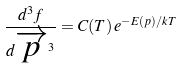Convert formula to latex. <formula><loc_0><loc_0><loc_500><loc_500>\frac { d ^ { 3 } f } { d \overrightarrow { p } ^ { 3 } } = C ( T ) \, e ^ { - E ( p ) / k T }</formula> 